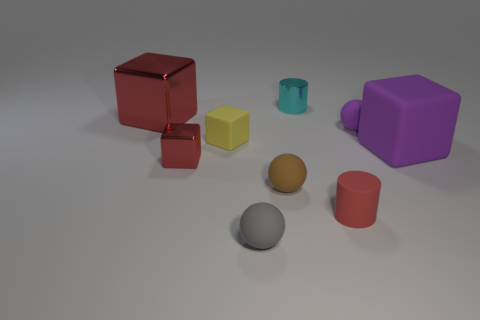Does the big rubber thing have the same color as the big shiny thing?
Ensure brevity in your answer.  No. How many large objects are metallic blocks or rubber cylinders?
Make the answer very short. 1. Is there anything else that is the same color as the tiny metallic cube?
Offer a very short reply. Yes. There is a tiny brown thing; are there any big purple rubber objects to the right of it?
Offer a terse response. Yes. There is a metal object that is behind the red cube behind the tiny red metallic cube; what size is it?
Give a very brief answer. Small. Is the number of tiny yellow matte objects that are on the right side of the shiny cylinder the same as the number of cylinders behind the large red shiny block?
Make the answer very short. No. There is a cylinder behind the red rubber cylinder; are there any big red blocks that are behind it?
Make the answer very short. No. What number of gray balls are behind the big block behind the purple rubber object that is to the left of the big purple matte object?
Your answer should be very brief. 0. Are there fewer tiny brown rubber balls than big purple metal cylinders?
Ensure brevity in your answer.  No. There is a small thing behind the large red shiny object; is its shape the same as the purple rubber object left of the big purple block?
Offer a terse response. No. 